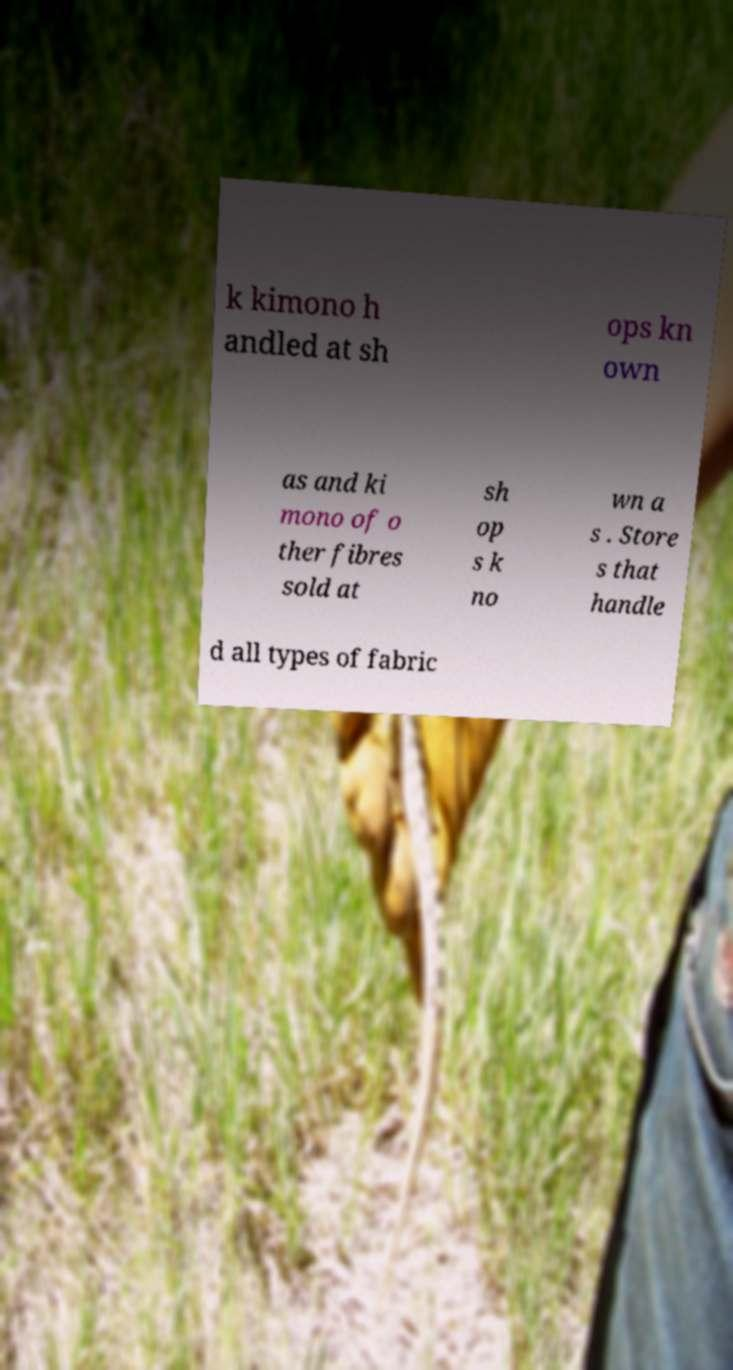Can you read and provide the text displayed in the image?This photo seems to have some interesting text. Can you extract and type it out for me? k kimono h andled at sh ops kn own as and ki mono of o ther fibres sold at sh op s k no wn a s . Store s that handle d all types of fabric 